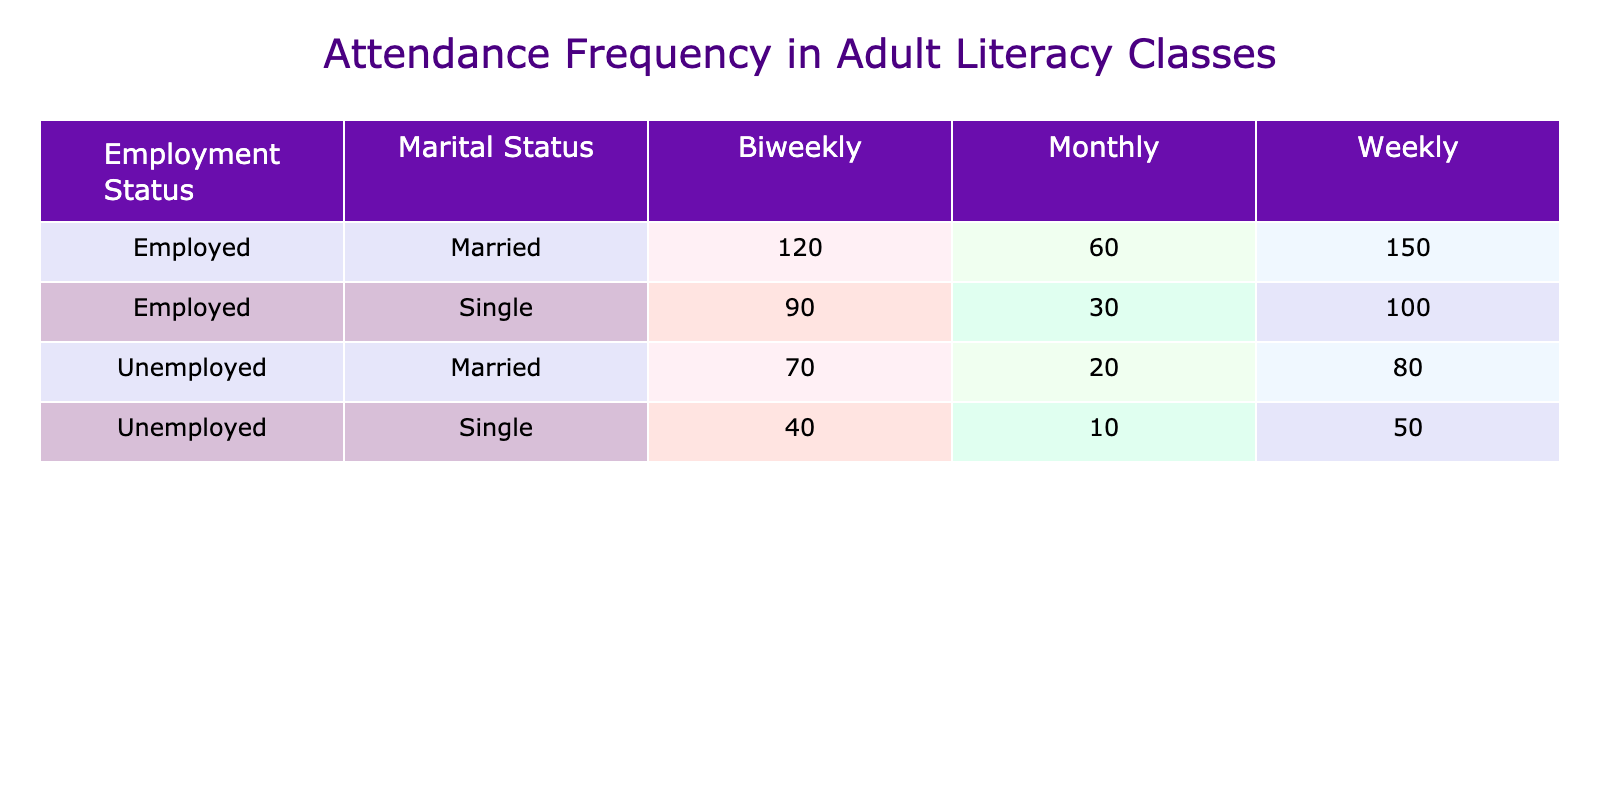What is the total attendance of unemployed individuals attending classes biweekly? To find the total attendance for unemployed individuals attending classes biweekly, we look at the relevant rows in the table. There are two groups: Unemployed, Married (70) and Unemployed, Single (40). Adding these counts gives us 70 + 40 = 110.
Answer: 110 How many employed individuals attend literacy classes monthly? We look at the rows for employed individuals under the monthly attendance category. The counts are 60 for Employed, Married and 30 for Employed, Single. Summing these values gives us 60 + 30 = 90.
Answer: 90 Is there a higher attendance frequency for married or single individuals? To address this, we need to compare the total counts for married and single individuals across all attendance frequencies. The total for married individuals is 150 + 80 + 120 + 70 + 60 + 20 = 500. For single individuals, the total is 100 + 50 + 90 + 40 + 30 + 10 = 320. Since 500 > 320, married individuals have a higher attendance frequency.
Answer: Yes What is the difference in attendance counts for employed individuals between weekly and monthly classes? The count of employed individuals attending classes weekly is 150 (Married) + 100 (Single) = 250. For monthly, it is 60 (Married) + 30 (Single) = 90. The difference is 250 - 90 = 160.
Answer: 160 Which marital status has more attendance in the biweekly category? We compare the counts for married and single individuals in the biweekly category. Married individuals have 120 (Employed) + 70 (Unemployed) = 190. Single individuals have 90 (Employed) + 40 (Unemployed) = 130. Since 190 > 130, married individuals have more attendance in this category.
Answer: Married What is the average attendance frequency for unemployed individuals? To compute the average count for unemployed individuals, we first list their attendance: 80 (Married, Weekly) + 50 (Single, Weekly) + 70 (Married, Biweekly) + 40 (Single, Biweekly) + 20 (Married, Monthly) + 10 (Single, Monthly) = 270. There are 6 data points (each unique condition). So, the average is 270 / 6 = 45.
Answer: 45 